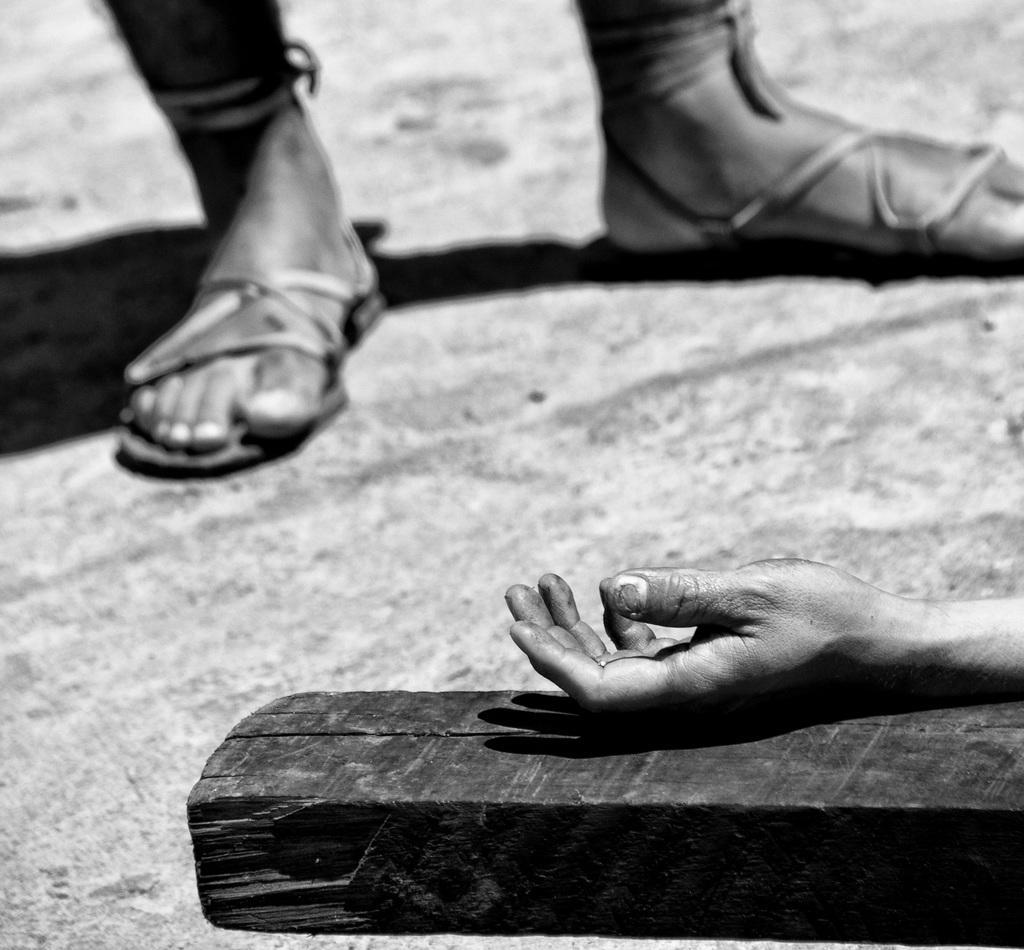Can you describe this image briefly? This is a black and white pic. At the bottom we can see a person´s hand on a wooden piece on the ground. At the top we can see person's legs and shadow on the ground. 